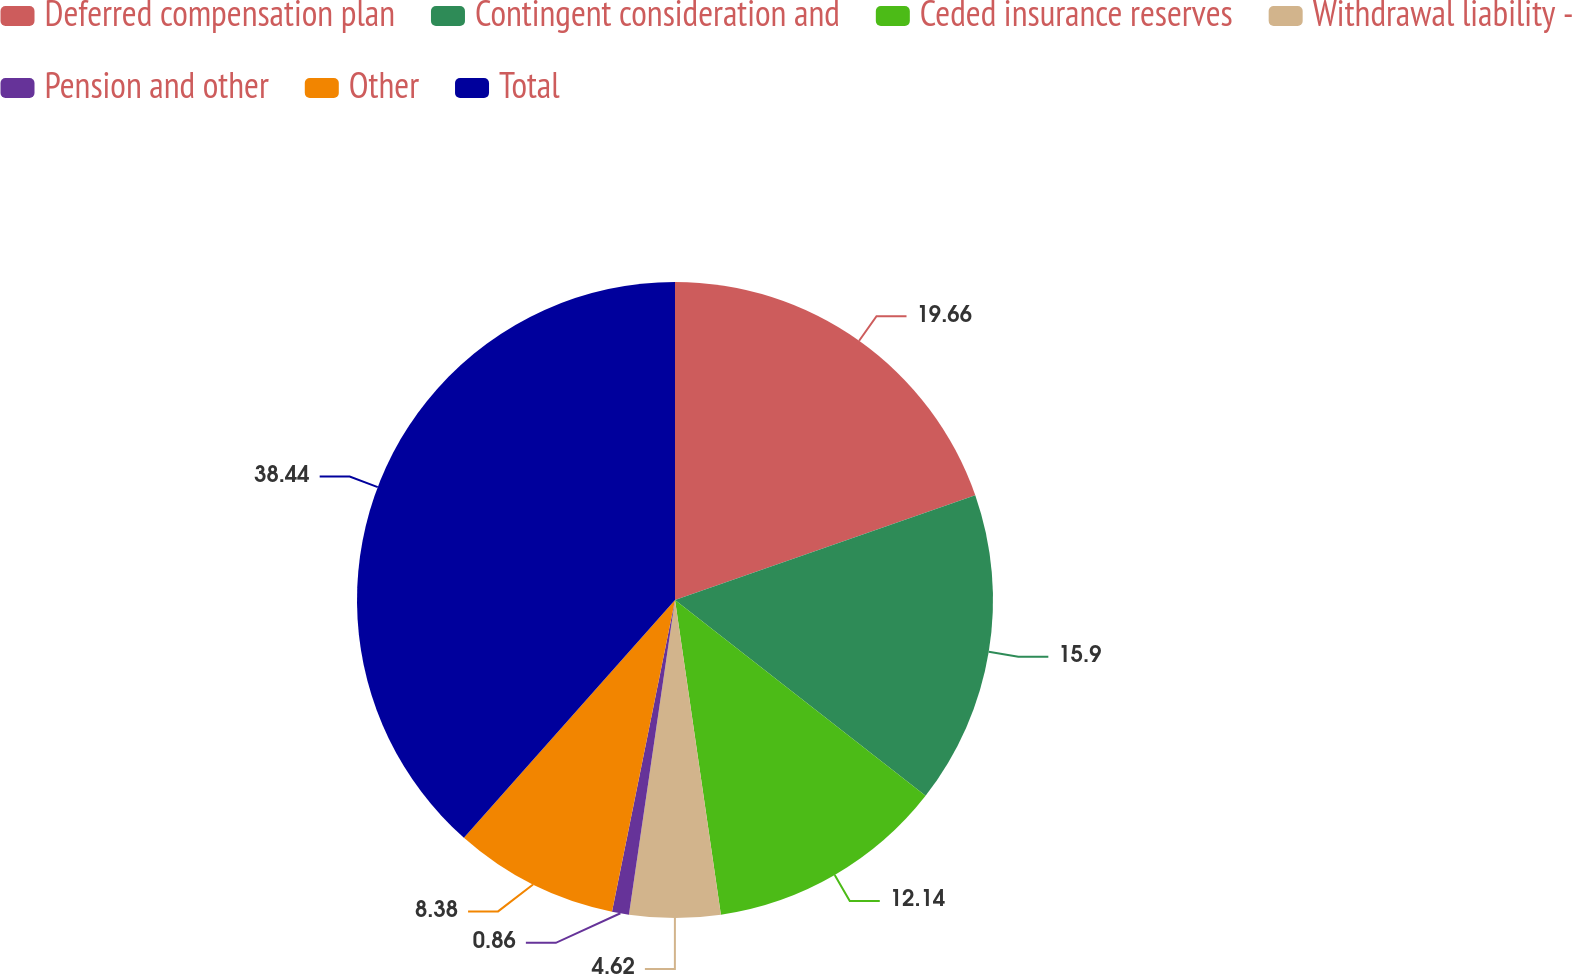<chart> <loc_0><loc_0><loc_500><loc_500><pie_chart><fcel>Deferred compensation plan<fcel>Contingent consideration and<fcel>Ceded insurance reserves<fcel>Withdrawal liability -<fcel>Pension and other<fcel>Other<fcel>Total<nl><fcel>19.66%<fcel>15.9%<fcel>12.14%<fcel>4.62%<fcel>0.86%<fcel>8.38%<fcel>38.45%<nl></chart> 